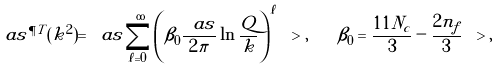<formula> <loc_0><loc_0><loc_500><loc_500>\ a s ^ { \P T } ( k ^ { 2 } ) = \ a s \sum _ { \ell = 0 } ^ { \infty } \left ( \beta _ { 0 } \frac { \ a s } { 2 \pi } \ln \frac { Q } { k } \right ) ^ { \ell } \ > , \quad \beta _ { 0 } = \frac { 1 1 N _ { c } } { 3 } - \frac { 2 n _ { f } } { 3 } \ > ,</formula> 